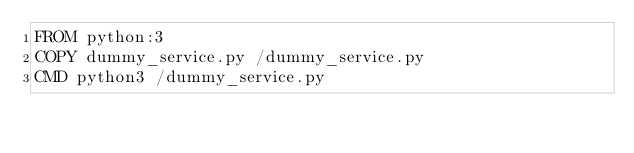Convert code to text. <code><loc_0><loc_0><loc_500><loc_500><_Dockerfile_>FROM python:3
COPY dummy_service.py /dummy_service.py
CMD python3 /dummy_service.py
</code> 